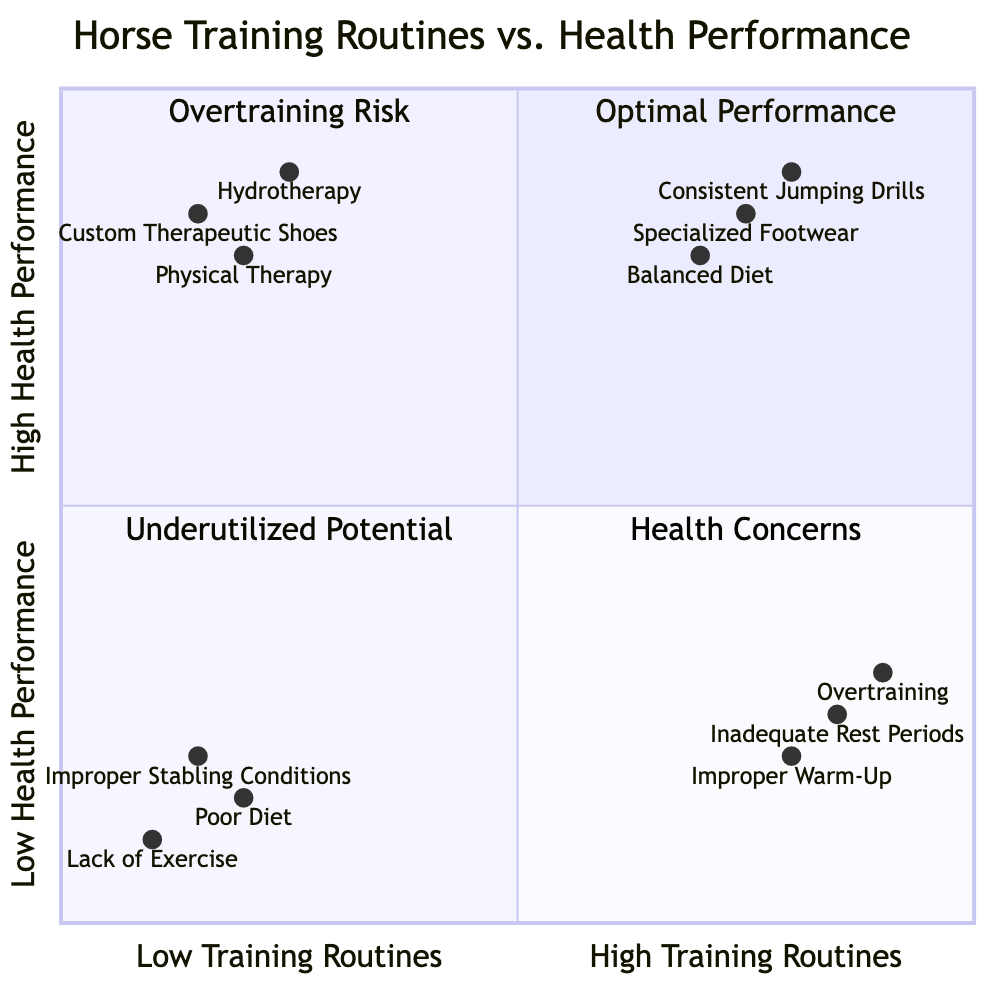What are the elements in the "High Training Routines/High Health Performance" quadrant? The "High Training Routines/High Health Performance" quadrant contains three elements: Consistent Jumping Drills, Balanced Diet, and Specialized Footwear. These elements contribute positively to both training and health performance.
Answer: Consistent Jumping Drills, Balanced Diet, Specialized Footwear What is the label of the element located at coordinates [0.2, 0.15]? The element located at coordinates [0.2, 0.15] is Poor Diet, as it corresponds to the Low Training Routines/Low Health Performance quadrant according to the given coordinates.
Answer: Poor Diet How many elements are there in the "Low Training Routines/High Health Performance" quadrant? The "Low Training Routines/High Health Performance" quadrant contains three elements: Physical Therapy, Custom Therapeutic Shoes, and Hydrotherapy. Therefore, there are a total of three elements in this quadrant.
Answer: 3 Which element has the highest training routine but the lowest health performance? The element with the highest training routine but the lowest health performance is Overtraining, which indicates a high level of training without adequate health benefits.
Answer: Overtraining Which quadrant contains "Improper Warm-Up"? The "Improper Warm-Up" element is located in the "High Training Routines/Low Health Performance" quadrant, where it highlights the risks associated with inadequate warm-up exercises leading to injuries.
Answer: High Training Routines/Low Health Performance What is the relationship between "Custom Therapeutic Shoes" and "Specialized Footwear"? "Custom Therapeutic Shoes" and "Specialized Footwear" both focus on optimizing the horse's physical training and health, but "Custom Therapeutic Shoes" is situated in the "Low Training Routines/High Health Performance" quadrant, indicating less training but significant health support, whereas "Specialized Footwear" aims for balance and reduced stress in the "High Training Routines/High Health Performance" quadrant.
Answer: Health support emphasis Which quadrant is at risk due to "Inadequate Rest Periods"? The "Inadequate Rest Periods" element is positioned in the "High Training Routines/Low Health Performance" quadrant, indicating a risk associated with training without allowing sufficient recovery time for the horse.
Answer: High Training Routines/Low Health Performance What is the defining characteristic of the "Low Training Routines/Low Health Performance" quadrant? The defining characteristic of the "Low Training Routines/Low Health Performance" quadrant is that it includes elements reflecting poor physical activity, such as Lack of Exercise, Poor Diet, and Improper Stabling Conditions, which lead to suboptimal health and performance.
Answer: Poor physical activity Which element in the "Low Training Routines/High Health Performance" quadrant focuses on prevention? The element focusing on prevention in the "Low Training Routines/High Health Performance" quadrant is Physical Therapy, which addresses and prevents orthopedic issues through regular sessions.
Answer: Physical Therapy 